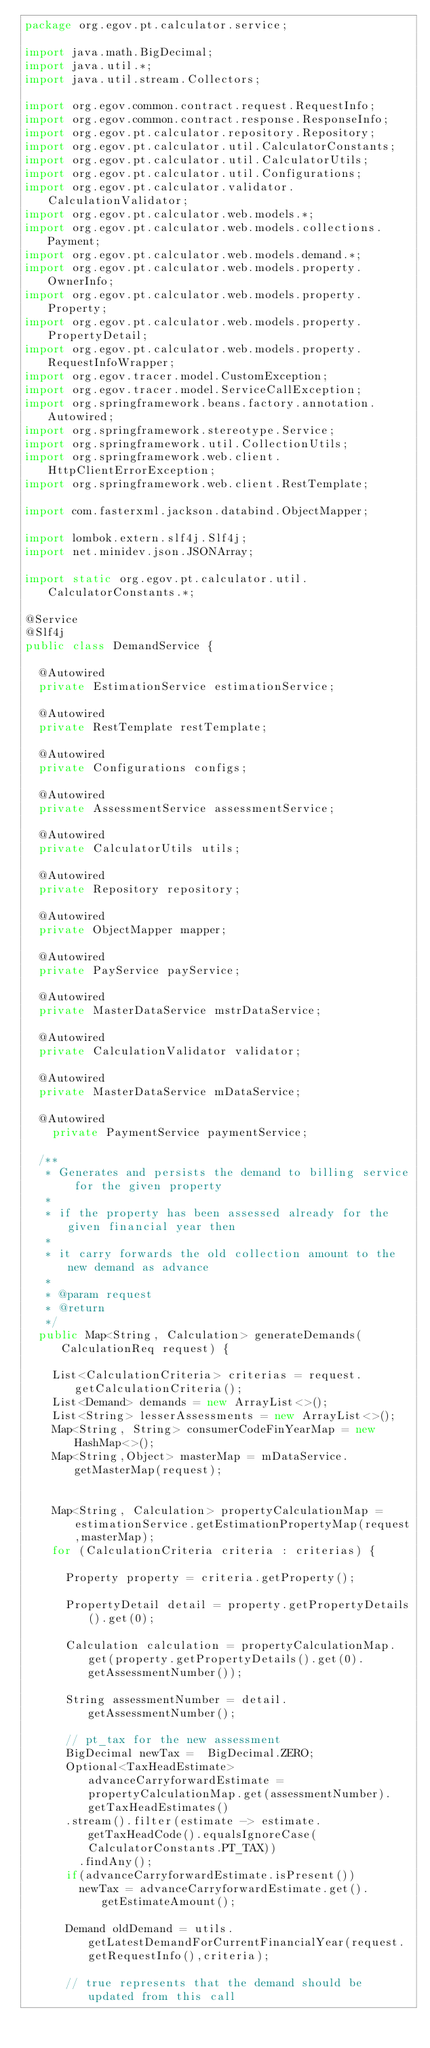Convert code to text. <code><loc_0><loc_0><loc_500><loc_500><_Java_>package org.egov.pt.calculator.service;

import java.math.BigDecimal;
import java.util.*;
import java.util.stream.Collectors;

import org.egov.common.contract.request.RequestInfo;
import org.egov.common.contract.response.ResponseInfo;
import org.egov.pt.calculator.repository.Repository;
import org.egov.pt.calculator.util.CalculatorConstants;
import org.egov.pt.calculator.util.CalculatorUtils;
import org.egov.pt.calculator.util.Configurations;
import org.egov.pt.calculator.validator.CalculationValidator;
import org.egov.pt.calculator.web.models.*;
import org.egov.pt.calculator.web.models.collections.Payment;
import org.egov.pt.calculator.web.models.demand.*;
import org.egov.pt.calculator.web.models.property.OwnerInfo;
import org.egov.pt.calculator.web.models.property.Property;
import org.egov.pt.calculator.web.models.property.PropertyDetail;
import org.egov.pt.calculator.web.models.property.RequestInfoWrapper;
import org.egov.tracer.model.CustomException;
import org.egov.tracer.model.ServiceCallException;
import org.springframework.beans.factory.annotation.Autowired;
import org.springframework.stereotype.Service;
import org.springframework.util.CollectionUtils;
import org.springframework.web.client.HttpClientErrorException;
import org.springframework.web.client.RestTemplate;

import com.fasterxml.jackson.databind.ObjectMapper;

import lombok.extern.slf4j.Slf4j;
import net.minidev.json.JSONArray;

import static org.egov.pt.calculator.util.CalculatorConstants.*;

@Service
@Slf4j
public class DemandService {

	@Autowired
	private EstimationService estimationService;

	@Autowired
	private RestTemplate restTemplate;

	@Autowired
	private Configurations configs;

	@Autowired
	private AssessmentService assessmentService;

	@Autowired
	private CalculatorUtils utils;

	@Autowired
	private Repository repository;

	@Autowired
	private ObjectMapper mapper;

	@Autowired
	private PayService payService;

	@Autowired
	private MasterDataService mstrDataService;

	@Autowired
	private CalculationValidator validator;

	@Autowired
	private MasterDataService mDataService;

	@Autowired
    private PaymentService paymentService;

	/**
	 * Generates and persists the demand to billing service for the given property
	 * 
	 * if the property has been assessed already for the given financial year then
	 * 
	 * it carry forwards the old collection amount to the new demand as advance
	 * 
	 * @param request
	 * @return
	 */
	public Map<String, Calculation> generateDemands(CalculationReq request) {

		List<CalculationCriteria> criterias = request.getCalculationCriteria();
		List<Demand> demands = new ArrayList<>();
		List<String> lesserAssessments = new ArrayList<>();
		Map<String, String> consumerCodeFinYearMap = new HashMap<>();
		Map<String,Object> masterMap = mDataService.getMasterMap(request);


		Map<String, Calculation> propertyCalculationMap = estimationService.getEstimationPropertyMap(request,masterMap);
		for (CalculationCriteria criteria : criterias) {

			Property property = criteria.getProperty();

			PropertyDetail detail = property.getPropertyDetails().get(0);

			Calculation calculation = propertyCalculationMap.get(property.getPropertyDetails().get(0).getAssessmentNumber());

			String assessmentNumber = detail.getAssessmentNumber();

			// pt_tax for the new assessment
			BigDecimal newTax =  BigDecimal.ZERO;
			Optional<TaxHeadEstimate> advanceCarryforwardEstimate = propertyCalculationMap.get(assessmentNumber).getTaxHeadEstimates()
			.stream().filter(estimate -> estimate.getTaxHeadCode().equalsIgnoreCase(CalculatorConstants.PT_TAX))
				.findAny();
			if(advanceCarryforwardEstimate.isPresent())
				newTax = advanceCarryforwardEstimate.get().getEstimateAmount();

			Demand oldDemand = utils.getLatestDemandForCurrentFinancialYear(request.getRequestInfo(),criteria);

			// true represents that the demand should be updated from this call</code> 